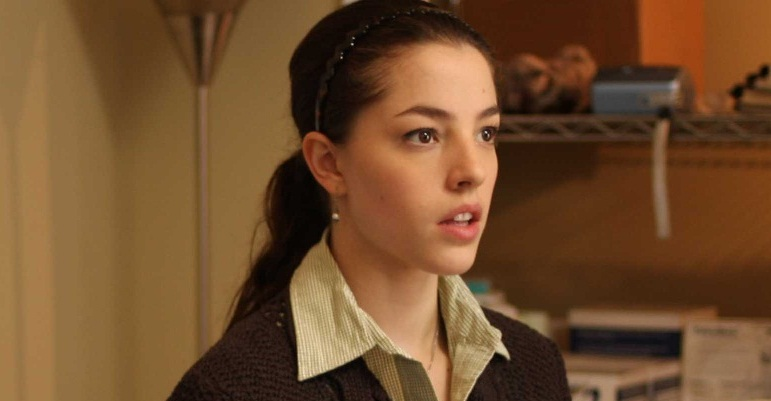What might the woman be thinking about? Consider both mundane and profound possibilities. The woman's expression suggests she could be contemplating a range of thoughts, from the mundane to the profound. On a mundane level, she might be thinking about a grocery list, planning her day, or recalling a conversation she had earlier. On a more profound level, she could be reflecting on a personal dilemma or decision that requires careful thought. Perhaps she is reminiscing about a pivotal moment in her past, contemplating her future, or even pondering existential questions about her life's purpose and direction. Her focused and serious expression indicates that whatever she is thinking about, it holds significant weight in her mind at this moment. Imagine that the woman is in a fantasy world. What role would she play and what kind of environment is she in? In a fantasy world, the woman might be a keeper of ancient knowledge or a guardian of mystical artifacts. Her environment could be an ancient library filled with scrolls and tomes containing the secrets of her world, a place lit by the flickering glow of enchanted candles. Perhaps she holds a key role in decoding a prophecy that could save her land from an impending darkness. She could also be a healer or a seer, someone whose wisdom is sought after by many. The quiet intensity in her eyes hints at the weight of her responsibility and the profound knowledge she carries, making her an indispensable character in the intricate lore of her world. 